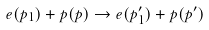Convert formula to latex. <formula><loc_0><loc_0><loc_500><loc_500>e ( p _ { 1 } ) + p ( p ) \to e ( p _ { 1 } ^ { \prime } ) + p ( p ^ { \prime } )</formula> 